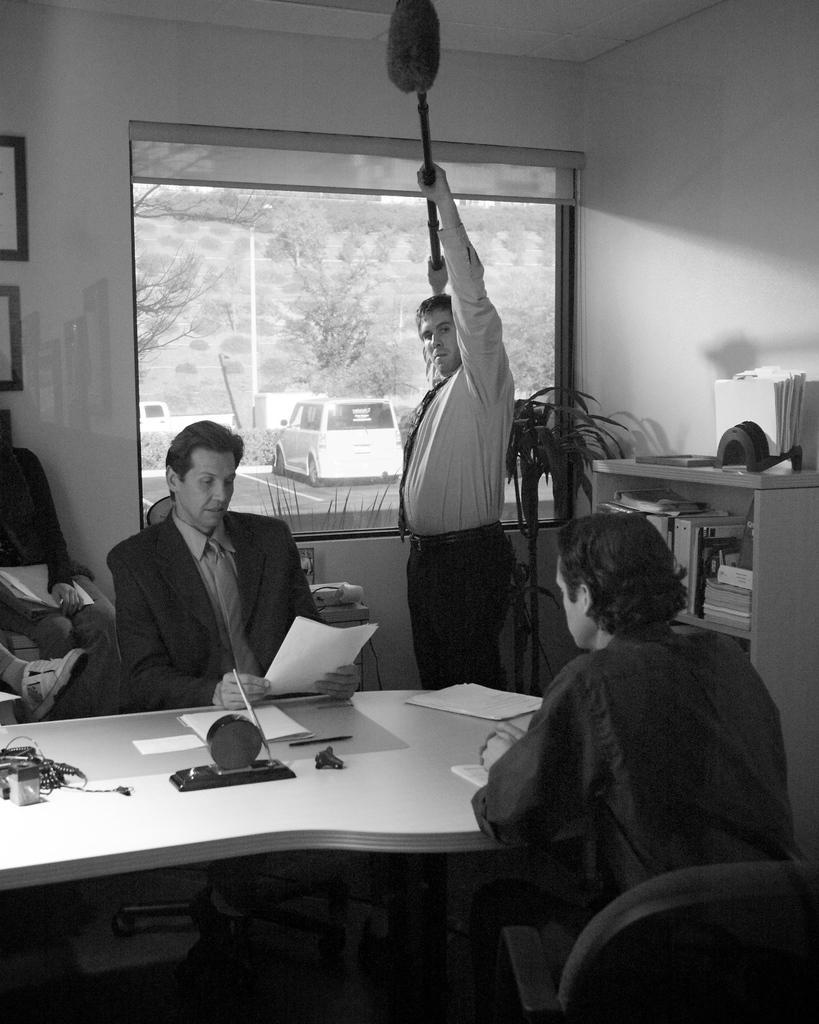How would you summarize this image in a sentence or two? In this image there are 2 persons sitting in a chair near the table another person standing , and the back ground there is plant, rack , books , tree , car. 